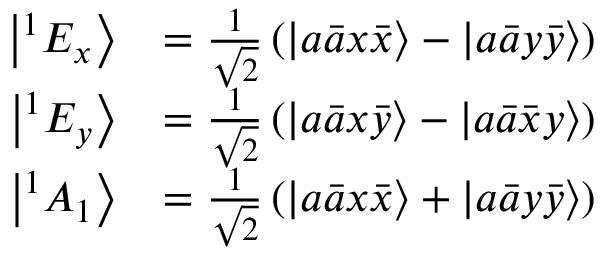Convert formula to latex. <formula><loc_0><loc_0><loc_500><loc_500>\begin{array} { r l } { \left | ^ { 1 } E _ { x } \right \rangle } & { = \frac { 1 } { \sqrt { 2 } } \left ( \left | a \bar { a } x \bar { x } \right \rangle - \left | a \bar { a } y \bar { y } \right \rangle \right ) } \\ { \left | ^ { 1 } E _ { y } \right \rangle } & { = \frac { 1 } { \sqrt { 2 } } \left ( \left | a \bar { a } x \bar { y } \right \rangle - \left | a \bar { a } \bar { x } y \right \rangle \right ) } \\ { \left | ^ { 1 } A _ { 1 } \right \rangle } & { = \frac { 1 } { \sqrt { 2 } } \left ( \left | a \bar { a } x \bar { x } \right \rangle + \left | a \bar { a } y \bar { y } \right \rangle \right ) } \end{array}</formula> 